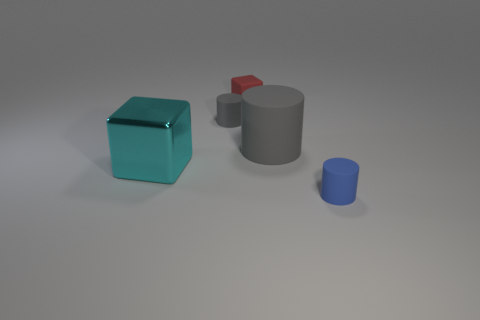Is the number of large gray things less than the number of yellow metallic spheres?
Offer a very short reply. No. Is the material of the gray cylinder in front of the small gray thing the same as the tiny red cube?
Keep it short and to the point. Yes. What number of cylinders are either blue objects or large gray matte things?
Ensure brevity in your answer.  2. There is a rubber object that is left of the blue object and in front of the tiny gray cylinder; what shape is it?
Provide a succinct answer. Cylinder. What color is the cube that is to the left of the small matte cylinder that is behind the tiny thing right of the large cylinder?
Your response must be concise. Cyan. Are there fewer rubber cylinders that are left of the tiny gray matte thing than small purple matte cylinders?
Provide a short and direct response. No. There is a matte thing that is in front of the cyan shiny cube; does it have the same shape as the large cyan thing that is to the left of the big gray object?
Provide a succinct answer. No. What number of things are tiny rubber things in front of the big cube or tiny objects?
Offer a terse response. 3. There is a gray rubber cylinder that is in front of the rubber cylinder left of the matte cube; is there a big cyan metal object behind it?
Ensure brevity in your answer.  No. Is the number of large gray cylinders that are on the left side of the rubber cube less than the number of objects that are to the right of the cyan metal object?
Offer a very short reply. Yes. 